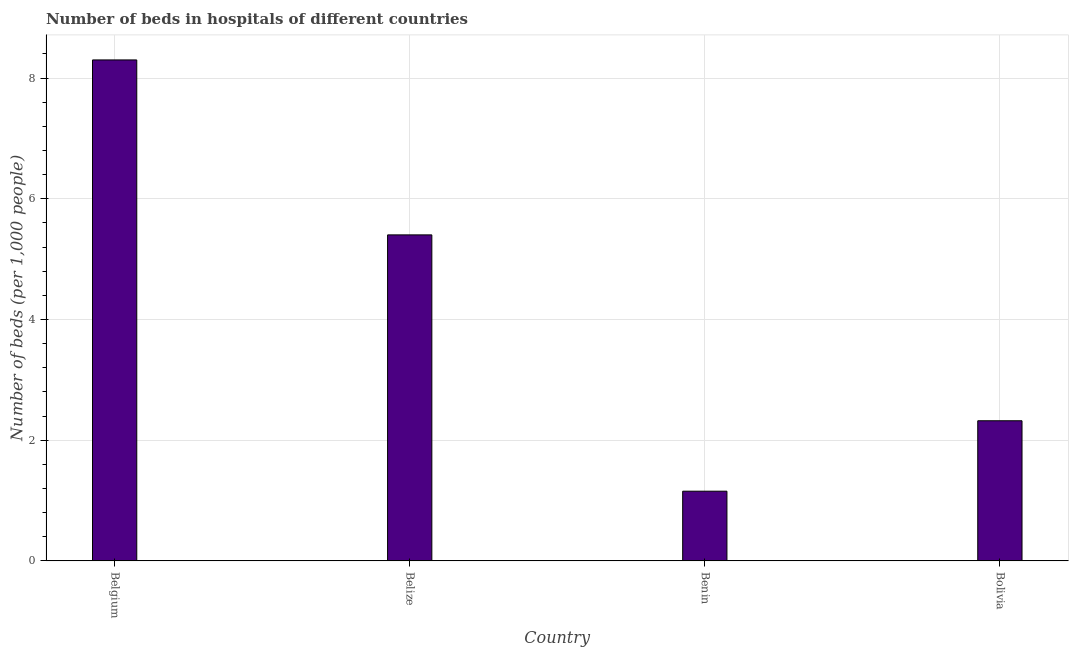Does the graph contain any zero values?
Offer a very short reply. No. Does the graph contain grids?
Offer a terse response. Yes. What is the title of the graph?
Your answer should be compact. Number of beds in hospitals of different countries. What is the label or title of the Y-axis?
Ensure brevity in your answer.  Number of beds (per 1,0 people). What is the number of hospital beds in Belize?
Ensure brevity in your answer.  5.4. Across all countries, what is the maximum number of hospital beds?
Provide a short and direct response. 8.3. Across all countries, what is the minimum number of hospital beds?
Provide a short and direct response. 1.15. In which country was the number of hospital beds maximum?
Provide a succinct answer. Belgium. In which country was the number of hospital beds minimum?
Provide a succinct answer. Benin. What is the sum of the number of hospital beds?
Your answer should be very brief. 17.18. What is the difference between the number of hospital beds in Belgium and Benin?
Your answer should be very brief. 7.14. What is the average number of hospital beds per country?
Provide a succinct answer. 4.29. What is the median number of hospital beds?
Your response must be concise. 3.86. In how many countries, is the number of hospital beds greater than 7.2 %?
Ensure brevity in your answer.  1. What is the ratio of the number of hospital beds in Belgium to that in Bolivia?
Your answer should be compact. 3.58. What is the difference between the highest and the second highest number of hospital beds?
Provide a succinct answer. 2.9. What is the difference between the highest and the lowest number of hospital beds?
Offer a very short reply. 7.15. In how many countries, is the number of hospital beds greater than the average number of hospital beds taken over all countries?
Your response must be concise. 2. How many bars are there?
Keep it short and to the point. 4. How many countries are there in the graph?
Make the answer very short. 4. What is the difference between two consecutive major ticks on the Y-axis?
Your answer should be very brief. 2. Are the values on the major ticks of Y-axis written in scientific E-notation?
Provide a short and direct response. No. What is the Number of beds (per 1,000 people) of Belgium?
Provide a short and direct response. 8.3. What is the Number of beds (per 1,000 people) of Belize?
Keep it short and to the point. 5.4. What is the Number of beds (per 1,000 people) in Benin?
Make the answer very short. 1.15. What is the Number of beds (per 1,000 people) of Bolivia?
Make the answer very short. 2.32. What is the difference between the Number of beds (per 1,000 people) in Belgium and Belize?
Keep it short and to the point. 2.9. What is the difference between the Number of beds (per 1,000 people) in Belgium and Benin?
Make the answer very short. 7.15. What is the difference between the Number of beds (per 1,000 people) in Belgium and Bolivia?
Offer a very short reply. 5.98. What is the difference between the Number of beds (per 1,000 people) in Belize and Benin?
Your answer should be compact. 4.25. What is the difference between the Number of beds (per 1,000 people) in Belize and Bolivia?
Give a very brief answer. 3.08. What is the difference between the Number of beds (per 1,000 people) in Benin and Bolivia?
Your answer should be compact. -1.17. What is the ratio of the Number of beds (per 1,000 people) in Belgium to that in Belize?
Ensure brevity in your answer.  1.54. What is the ratio of the Number of beds (per 1,000 people) in Belgium to that in Benin?
Provide a succinct answer. 7.19. What is the ratio of the Number of beds (per 1,000 people) in Belgium to that in Bolivia?
Ensure brevity in your answer.  3.58. What is the ratio of the Number of beds (per 1,000 people) in Belize to that in Benin?
Your answer should be compact. 4.68. What is the ratio of the Number of beds (per 1,000 people) in Belize to that in Bolivia?
Ensure brevity in your answer.  2.33. What is the ratio of the Number of beds (per 1,000 people) in Benin to that in Bolivia?
Your response must be concise. 0.5. 